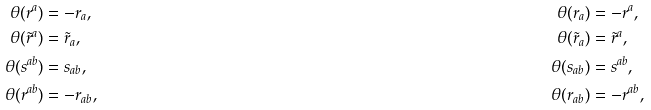<formula> <loc_0><loc_0><loc_500><loc_500>\theta ( r ^ { a } ) & = - r _ { a } , & \quad \theta ( r _ { a } ) & = - r ^ { a } , \\ \theta ( \tilde { r } ^ { a } ) & = \tilde { r } _ { a } , & \quad \theta ( \tilde { r } _ { a } ) & = \tilde { r } ^ { a } , \\ \theta ( s ^ { a b } ) & = s _ { a b } , & \quad \theta ( s _ { a b } ) & = s ^ { a b } , \\ \theta ( r ^ { a b } ) & = - r _ { a b } , & \quad \theta ( r _ { a b } ) & = - r ^ { a b } ,</formula> 